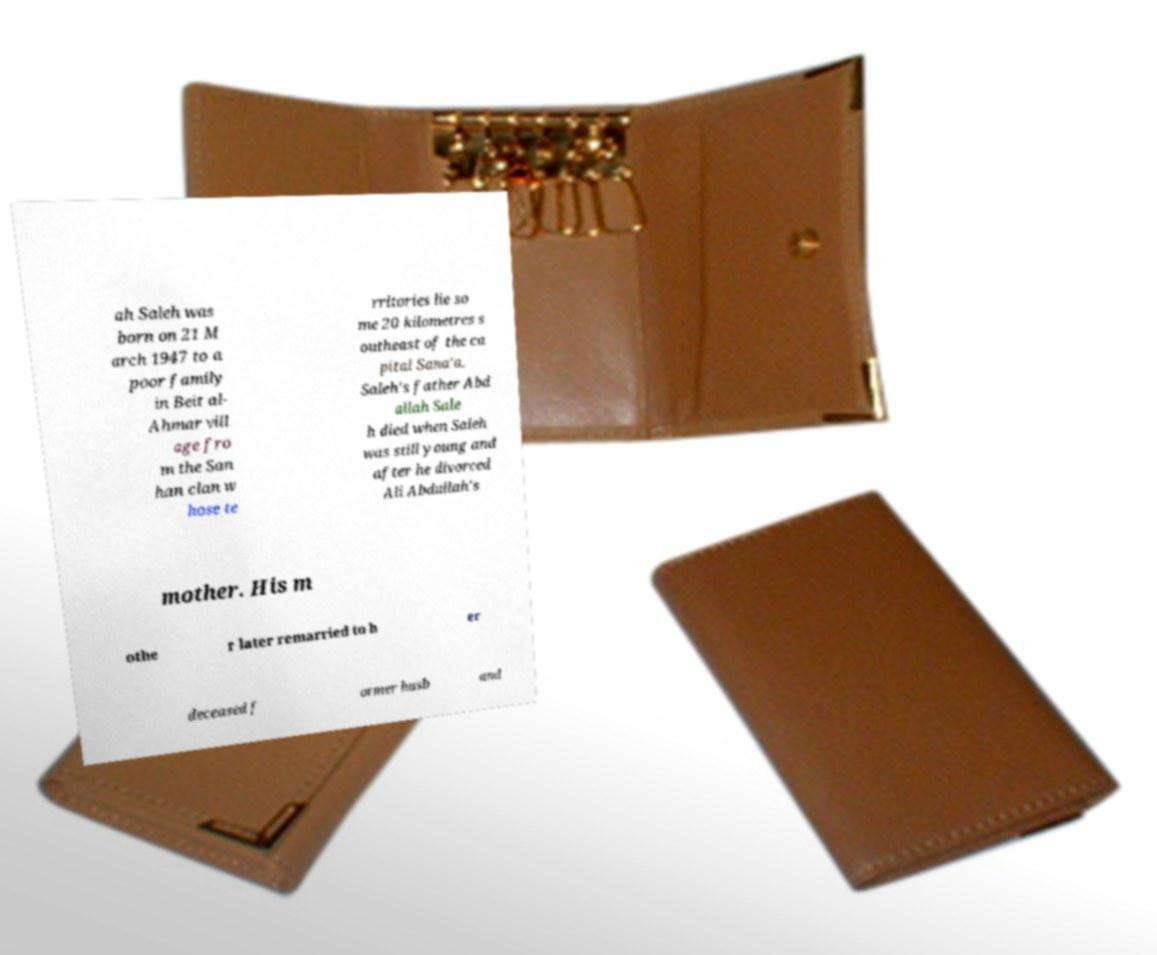Can you read and provide the text displayed in the image?This photo seems to have some interesting text. Can you extract and type it out for me? ah Saleh was born on 21 M arch 1947 to a poor family in Beit al- Ahmar vill age fro m the San han clan w hose te rritories lie so me 20 kilometres s outheast of the ca pital Sana'a. Saleh's father Abd allah Sale h died when Saleh was still young and after he divorced Ali Abdullah's mother. His m othe r later remarried to h er deceased f ormer husb and 